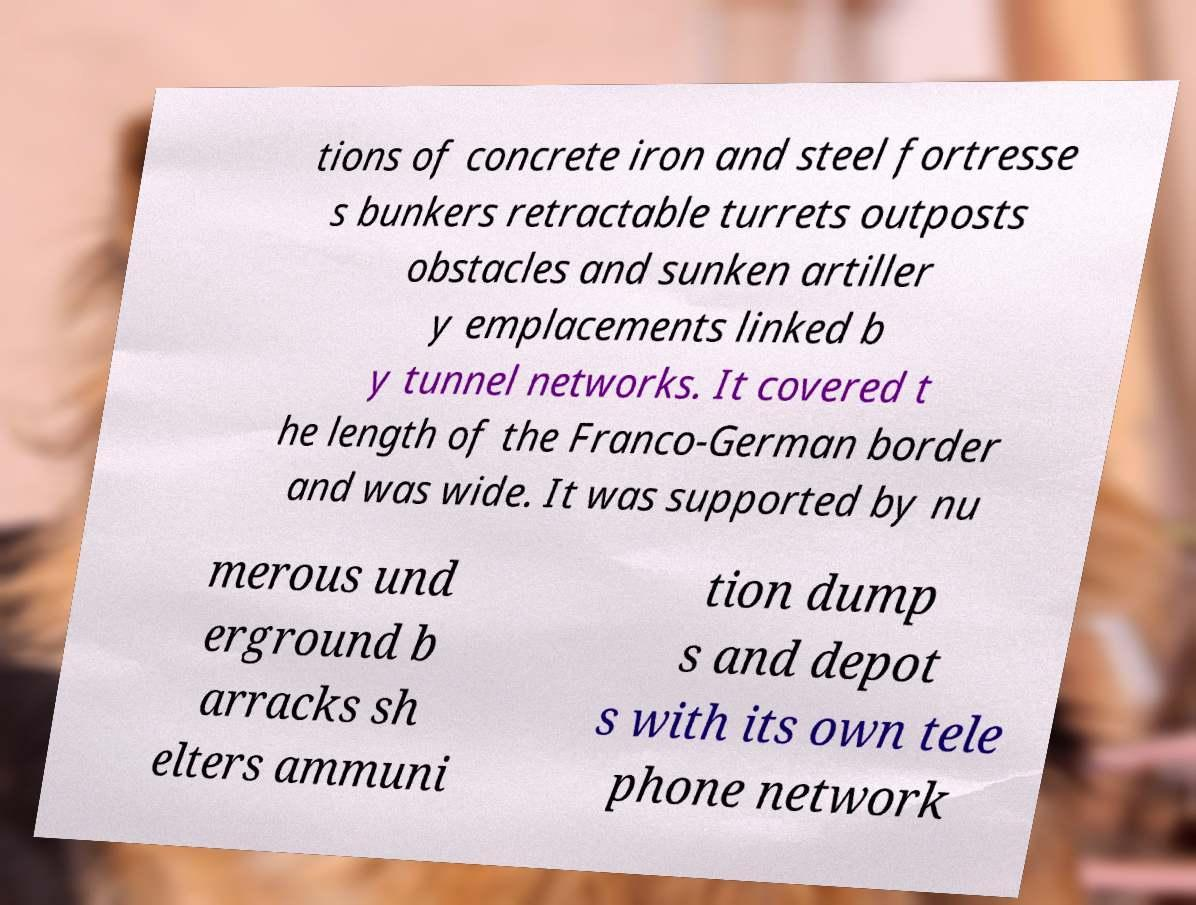For documentation purposes, I need the text within this image transcribed. Could you provide that? tions of concrete iron and steel fortresse s bunkers retractable turrets outposts obstacles and sunken artiller y emplacements linked b y tunnel networks. It covered t he length of the Franco-German border and was wide. It was supported by nu merous und erground b arracks sh elters ammuni tion dump s and depot s with its own tele phone network 